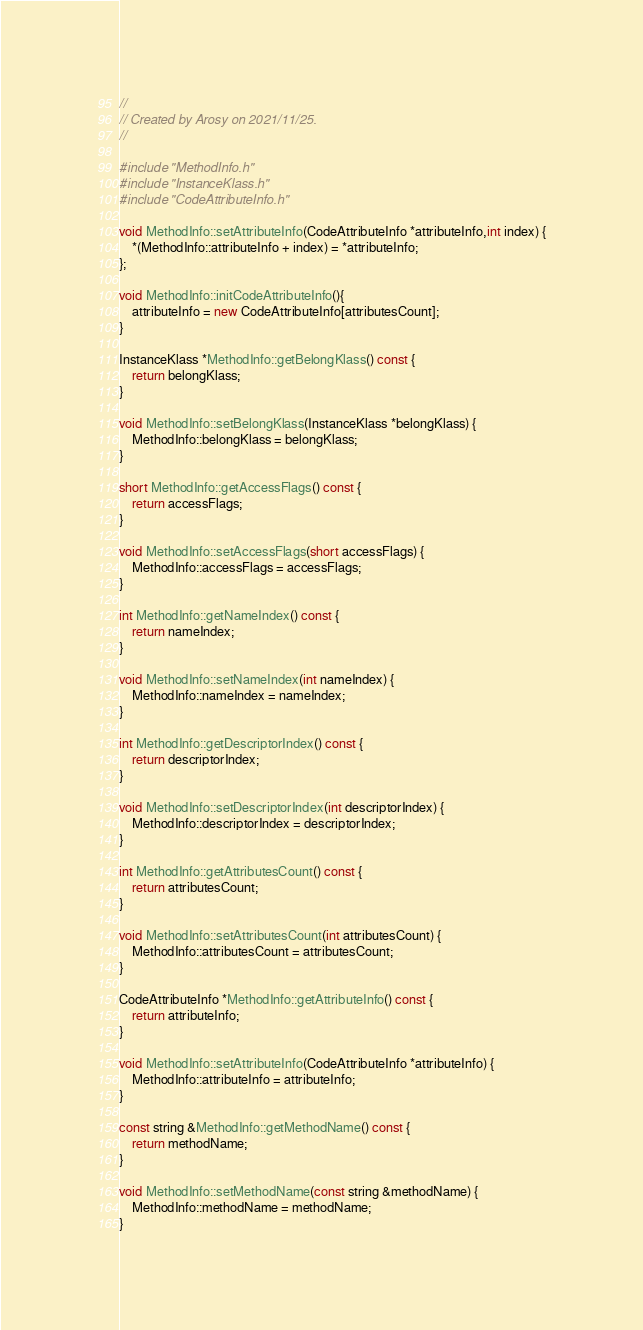<code> <loc_0><loc_0><loc_500><loc_500><_C++_>//
// Created by Arosy on 2021/11/25.
//

#include "MethodInfo.h"
#include "InstanceKlass.h"
#include "CodeAttributeInfo.h"

void MethodInfo::setAttributeInfo(CodeAttributeInfo *attributeInfo,int index) {
    *(MethodInfo::attributeInfo + index) = *attributeInfo;
};

void MethodInfo::initCodeAttributeInfo(){
    attributeInfo = new CodeAttributeInfo[attributesCount];
}

InstanceKlass *MethodInfo::getBelongKlass() const {
    return belongKlass;
}

void MethodInfo::setBelongKlass(InstanceKlass *belongKlass) {
    MethodInfo::belongKlass = belongKlass;
}

short MethodInfo::getAccessFlags() const {
    return accessFlags;
}

void MethodInfo::setAccessFlags(short accessFlags) {
    MethodInfo::accessFlags = accessFlags;
}

int MethodInfo::getNameIndex() const {
    return nameIndex;
}

void MethodInfo::setNameIndex(int nameIndex) {
    MethodInfo::nameIndex = nameIndex;
}

int MethodInfo::getDescriptorIndex() const {
    return descriptorIndex;
}

void MethodInfo::setDescriptorIndex(int descriptorIndex) {
    MethodInfo::descriptorIndex = descriptorIndex;
}

int MethodInfo::getAttributesCount() const {
    return attributesCount;
}

void MethodInfo::setAttributesCount(int attributesCount) {
    MethodInfo::attributesCount = attributesCount;
}

CodeAttributeInfo *MethodInfo::getAttributeInfo() const {
    return attributeInfo;
}

void MethodInfo::setAttributeInfo(CodeAttributeInfo *attributeInfo) {
    MethodInfo::attributeInfo = attributeInfo;
}

const string &MethodInfo::getMethodName() const {
    return methodName;
}

void MethodInfo::setMethodName(const string &methodName) {
    MethodInfo::methodName = methodName;
}
</code> 